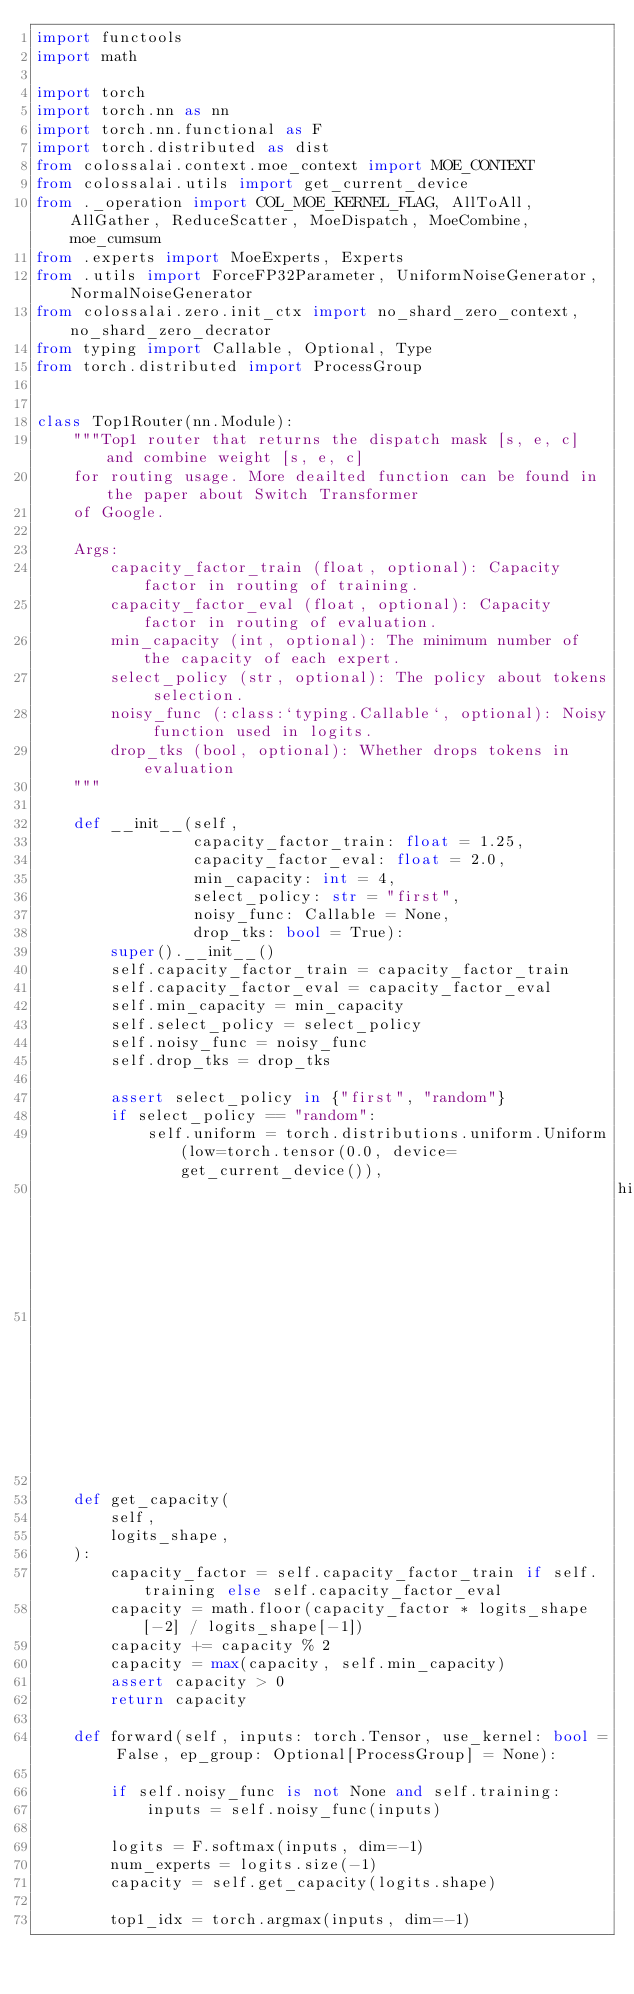<code> <loc_0><loc_0><loc_500><loc_500><_Python_>import functools
import math

import torch
import torch.nn as nn
import torch.nn.functional as F
import torch.distributed as dist
from colossalai.context.moe_context import MOE_CONTEXT
from colossalai.utils import get_current_device
from ._operation import COL_MOE_KERNEL_FLAG, AllToAll, AllGather, ReduceScatter, MoeDispatch, MoeCombine, moe_cumsum
from .experts import MoeExperts, Experts
from .utils import ForceFP32Parameter, UniformNoiseGenerator, NormalNoiseGenerator
from colossalai.zero.init_ctx import no_shard_zero_context, no_shard_zero_decrator
from typing import Callable, Optional, Type
from torch.distributed import ProcessGroup


class Top1Router(nn.Module):
    """Top1 router that returns the dispatch mask [s, e, c] and combine weight [s, e, c]
    for routing usage. More deailted function can be found in the paper about Switch Transformer
    of Google.

    Args:
        capacity_factor_train (float, optional): Capacity factor in routing of training.
        capacity_factor_eval (float, optional): Capacity factor in routing of evaluation.
        min_capacity (int, optional): The minimum number of the capacity of each expert.
        select_policy (str, optional): The policy about tokens selection.
        noisy_func (:class:`typing.Callable`, optional): Noisy function used in logits.
        drop_tks (bool, optional): Whether drops tokens in evaluation
    """

    def __init__(self,
                 capacity_factor_train: float = 1.25,
                 capacity_factor_eval: float = 2.0,
                 min_capacity: int = 4,
                 select_policy: str = "first",
                 noisy_func: Callable = None,
                 drop_tks: bool = True):
        super().__init__()
        self.capacity_factor_train = capacity_factor_train
        self.capacity_factor_eval = capacity_factor_eval
        self.min_capacity = min_capacity
        self.select_policy = select_policy
        self.noisy_func = noisy_func
        self.drop_tks = drop_tks

        assert select_policy in {"first", "random"}
        if select_policy == "random":
            self.uniform = torch.distributions.uniform.Uniform(low=torch.tensor(0.0, device=get_current_device()),
                                                               high=torch.tensor(1.0,
                                                                                 device=get_current_device())).rsample

    def get_capacity(
        self,
        logits_shape,
    ):
        capacity_factor = self.capacity_factor_train if self.training else self.capacity_factor_eval
        capacity = math.floor(capacity_factor * logits_shape[-2] / logits_shape[-1])
        capacity += capacity % 2
        capacity = max(capacity, self.min_capacity)
        assert capacity > 0
        return capacity

    def forward(self, inputs: torch.Tensor, use_kernel: bool = False, ep_group: Optional[ProcessGroup] = None):

        if self.noisy_func is not None and self.training:
            inputs = self.noisy_func(inputs)

        logits = F.softmax(inputs, dim=-1)
        num_experts = logits.size(-1)
        capacity = self.get_capacity(logits.shape)

        top1_idx = torch.argmax(inputs, dim=-1)</code> 